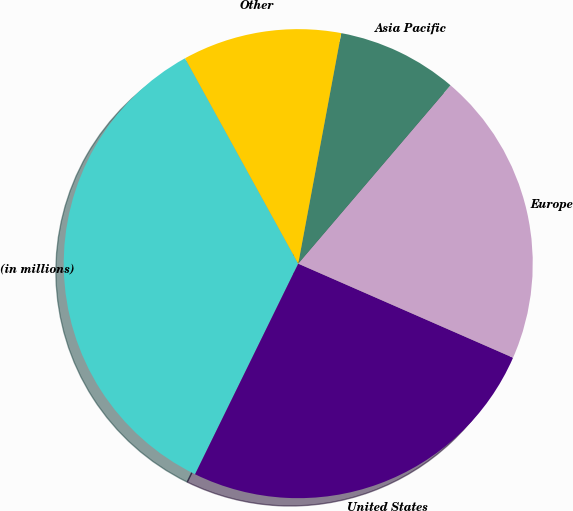<chart> <loc_0><loc_0><loc_500><loc_500><pie_chart><fcel>(in millions)<fcel>United States<fcel>Europe<fcel>Asia Pacific<fcel>Other<nl><fcel>34.73%<fcel>25.68%<fcel>20.32%<fcel>8.31%<fcel>10.95%<nl></chart> 